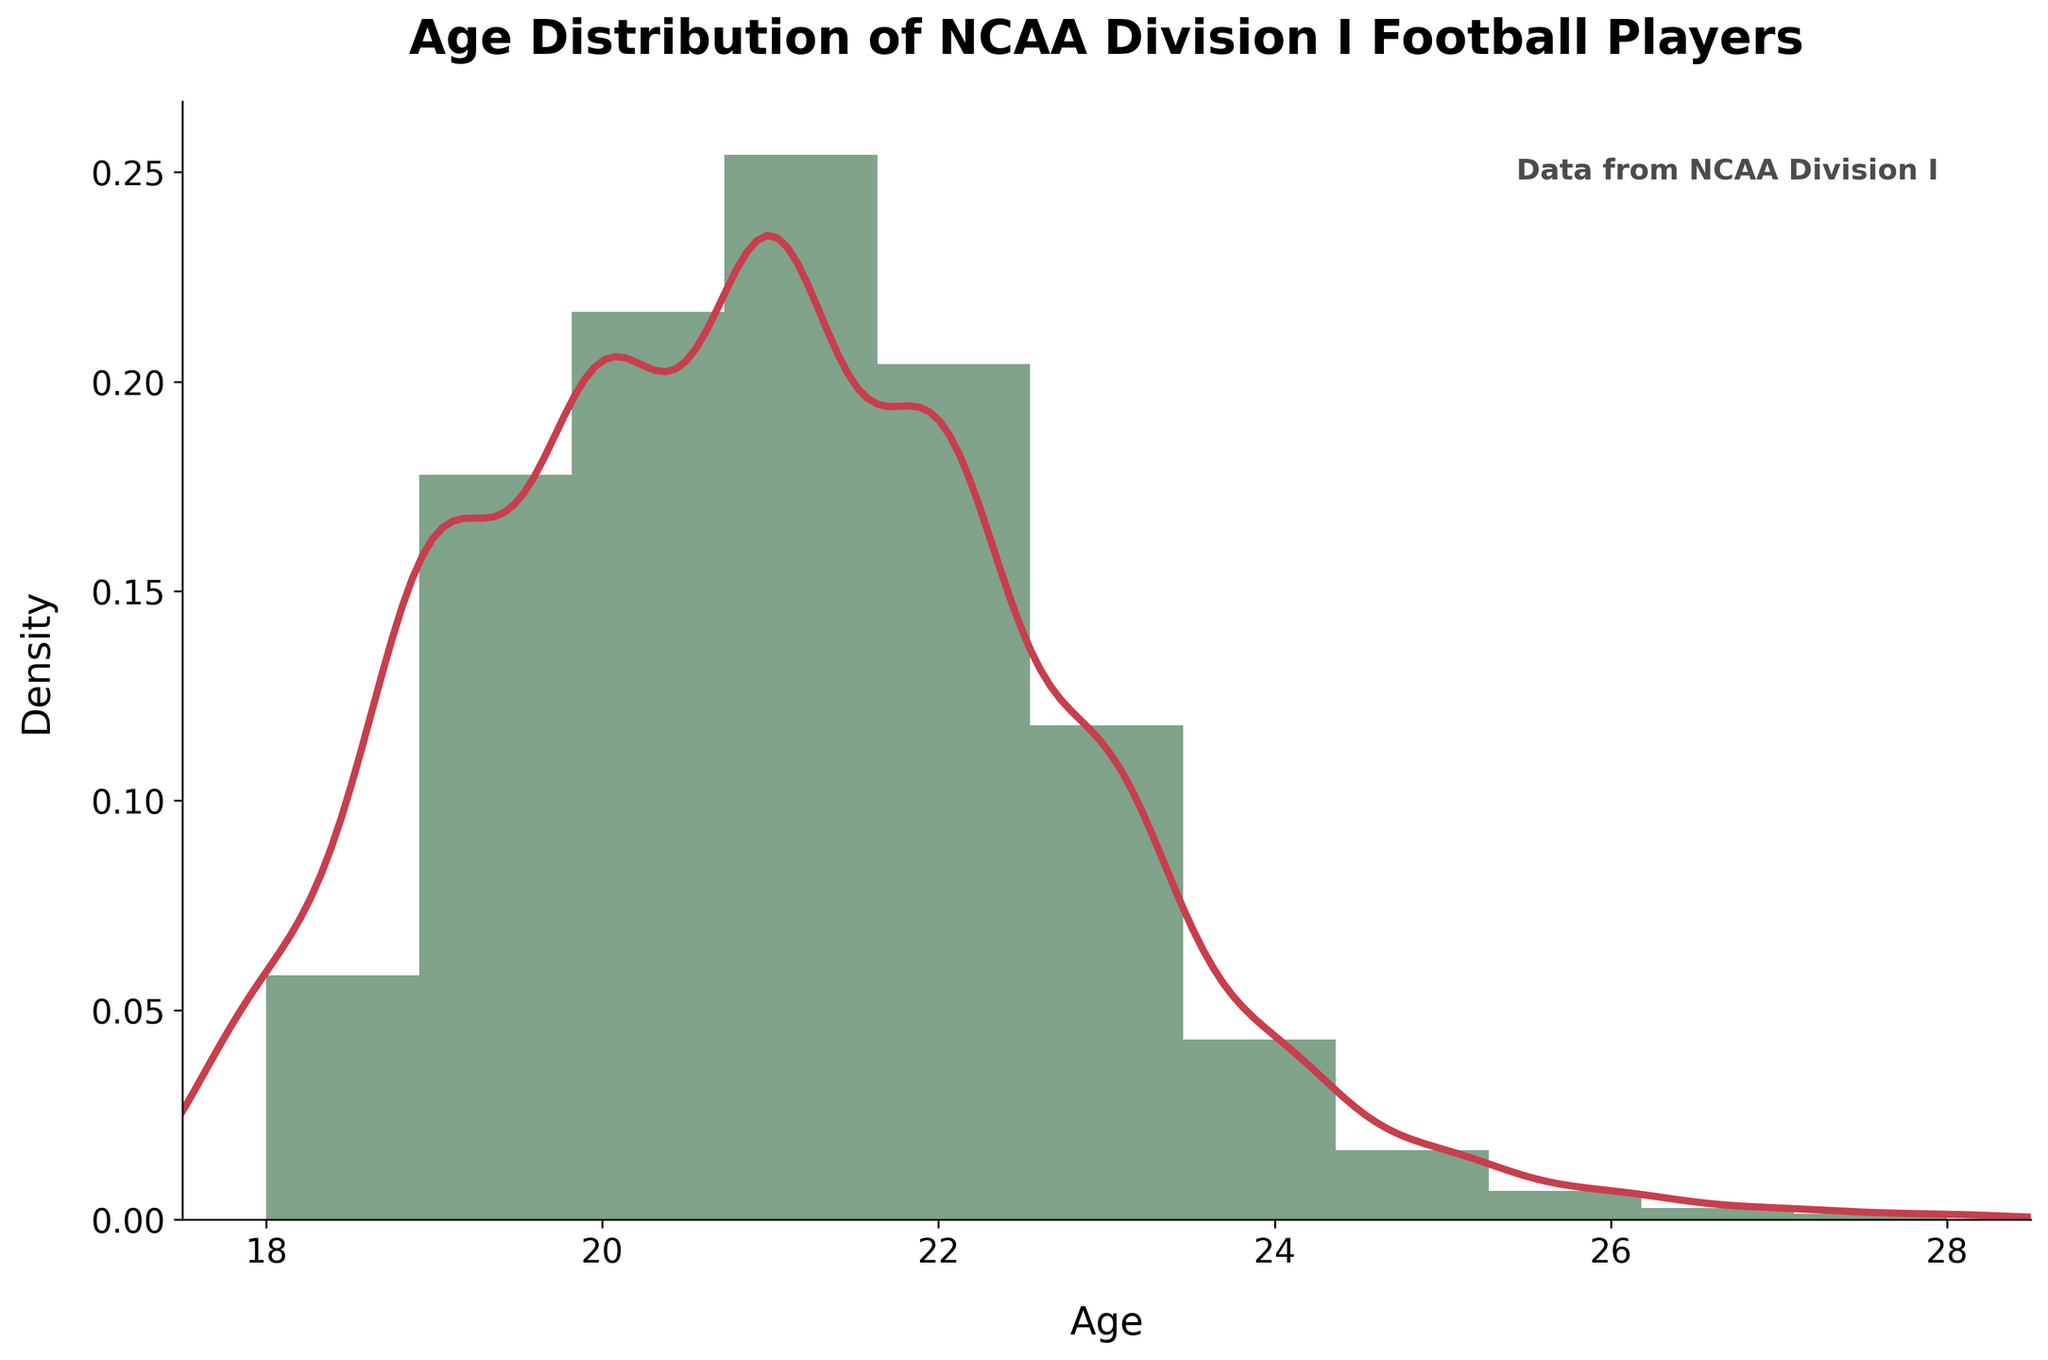what is the title of the figure? The title is often found at the top of the figure and summarizes what the figure represents. In this case, it's clearly written as "Age Distribution of NCAA Division I Football Players."
Answer: Age Distribution of NCAA Division I Football Players What is the age range displayed on the x-axis? The x-axis typically shows the range of data values. In this figure, the x-axis ranges from 18 to 28 years old, as indicated by the labeled ticks and the data points shown.
Answer: 18 to 28 years old At what age is the density of football players the highest? The highest density on a KDE plot is shown by the peak of the curve. Observing the figure, the peak of the KDE curve appears around 21 years.
Answer: 21 years old How many ages have a count of 100 or more players? To find this, you look at the bins in the histogram where the counts are 100 or more. There are bins for ages 19, 20, 21, and 22 that have counts above this threshold.
Answer: 4 ages Which age has the lowest count of football players? To find the age with the lowest count, look for the smallest bar in the histogram. The age of 28 shows the smallest count, indicated by the smallest bar in the figure.
Answer: 28 years old What is the combined count of football players aged 18 and 19? To calculate this, add the counts for ages 18 and 19. Referring to the data, 42 (age 18) + 128 (age 19) = 170
Answer: 170 Is the number of 23-year-old players greater than the number of 24 and 25-year-old players combined? Compare the counts: 23-year-olds have 85 players, while 24 and 25-year-olds combined have 31 + 12 = 43 players. 85 is indeed greater than 43.
Answer: Yes What is the average age of football players if we exclude ages above 25? To find the average, consider only ages 18 through 25. Calculate the total count and sum those ages' counts, then divide by the total count.
Sum of counts for ages 18 to 25: 42 + 128 + 156 + 183 + 147 + 85 + 31 + 12 = 784
Sum of ages' contribution: (18*42) + (19*128) + (20*156) + (21*183) + (22*147) + (23*85) + (24*31) + (25*12) = 16020
Average age = 16020 / 784 ≈ 20.45
Answer: 20.45 What is the overall shape of the density curve? The shape of the density curve illustrates the distribution of data. Observing it, the curve peaks at around 21 years and gently decreases towards the older ages, indicating a right-skewed distribution.
Answer: Right-skewed 